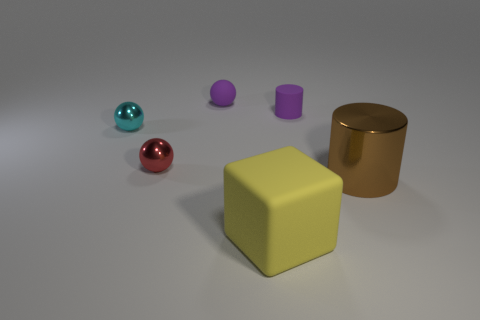Add 3 large blue metallic balls. How many objects exist? 9 Subtract all blocks. How many objects are left? 5 Add 5 large yellow rubber cubes. How many large yellow rubber cubes exist? 6 Subtract 0 brown balls. How many objects are left? 6 Subtract all cyan metallic things. Subtract all cylinders. How many objects are left? 3 Add 1 big blocks. How many big blocks are left? 2 